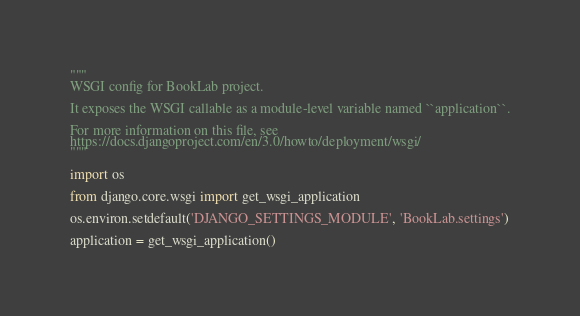<code> <loc_0><loc_0><loc_500><loc_500><_Python_>"""
WSGI config for BookLab project.

It exposes the WSGI callable as a module-level variable named ``application``.

For more information on this file, see
https://docs.djangoproject.com/en/3.0/howto/deployment/wsgi/
"""

import os

from django.core.wsgi import get_wsgi_application

os.environ.setdefault('DJANGO_SETTINGS_MODULE', 'BookLab.settings')

application = get_wsgi_application()
</code> 